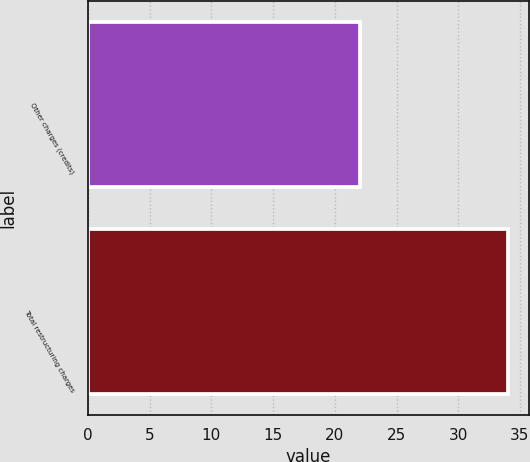Convert chart to OTSL. <chart><loc_0><loc_0><loc_500><loc_500><bar_chart><fcel>Other charges (credits)<fcel>Total restructuring charges<nl><fcel>22<fcel>34<nl></chart> 